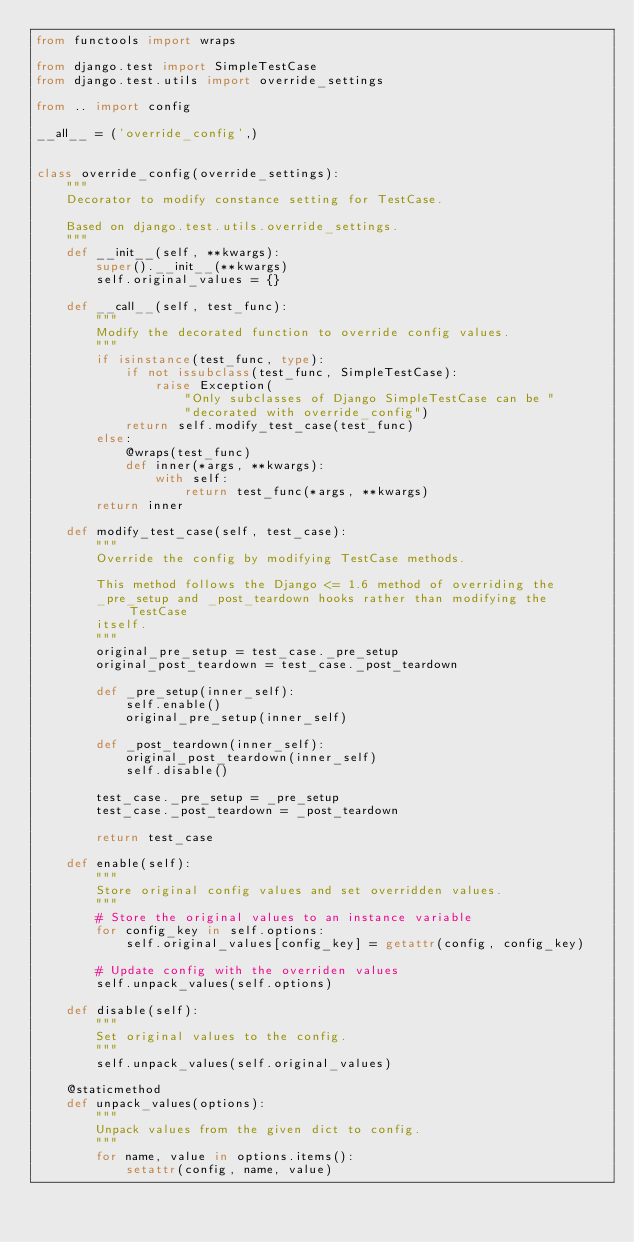Convert code to text. <code><loc_0><loc_0><loc_500><loc_500><_Python_>from functools import wraps

from django.test import SimpleTestCase
from django.test.utils import override_settings

from .. import config

__all__ = ('override_config',)


class override_config(override_settings):
    """
    Decorator to modify constance setting for TestCase.

    Based on django.test.utils.override_settings.
    """
    def __init__(self, **kwargs):
        super().__init__(**kwargs)
        self.original_values = {}

    def __call__(self, test_func):
        """
        Modify the decorated function to override config values.
        """
        if isinstance(test_func, type):
            if not issubclass(test_func, SimpleTestCase):
                raise Exception(
                    "Only subclasses of Django SimpleTestCase can be "
                    "decorated with override_config")
            return self.modify_test_case(test_func)
        else:
            @wraps(test_func)
            def inner(*args, **kwargs):
                with self:
                    return test_func(*args, **kwargs)
        return inner

    def modify_test_case(self, test_case):
        """
        Override the config by modifying TestCase methods.

        This method follows the Django <= 1.6 method of overriding the
        _pre_setup and _post_teardown hooks rather than modifying the TestCase
        itself.
        """
        original_pre_setup = test_case._pre_setup
        original_post_teardown = test_case._post_teardown

        def _pre_setup(inner_self):
            self.enable()
            original_pre_setup(inner_self)

        def _post_teardown(inner_self):
            original_post_teardown(inner_self)
            self.disable()

        test_case._pre_setup = _pre_setup
        test_case._post_teardown = _post_teardown

        return test_case

    def enable(self):
        """
        Store original config values and set overridden values.
        """
        # Store the original values to an instance variable
        for config_key in self.options:
            self.original_values[config_key] = getattr(config, config_key)

        # Update config with the overriden values
        self.unpack_values(self.options)

    def disable(self):
        """
        Set original values to the config.
        """
        self.unpack_values(self.original_values)

    @staticmethod
    def unpack_values(options):
        """
        Unpack values from the given dict to config.
        """
        for name, value in options.items():
            setattr(config, name, value)
</code> 